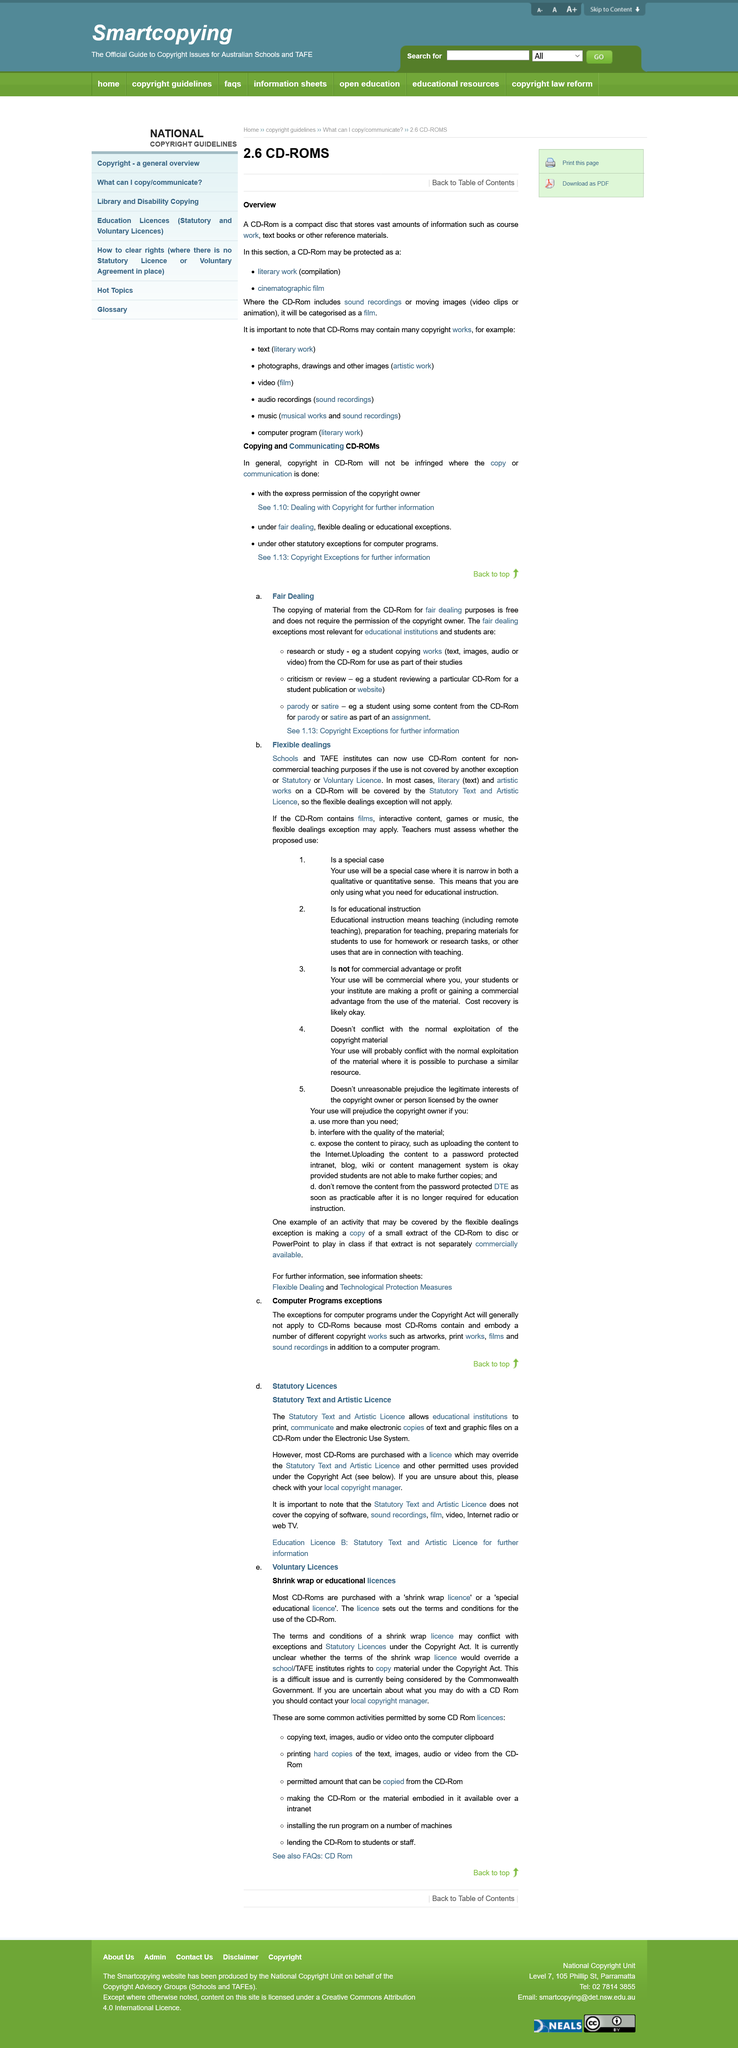Specify some key components in this picture. A CD-ROM that contains sound recordings or moving images will be categorized as a film. CD-Roms may contain multiple copyright works. The copying of material from a CD-Rom for fair dealing purposes does not require permission of the copyright owner. A CD-ROM can be protected as a cinematographic film and as a literary work, in addition to other forms of intellectual property. It is fair to copy material from a CD-Rom for purposes of fair dealing without incurring any cost. 